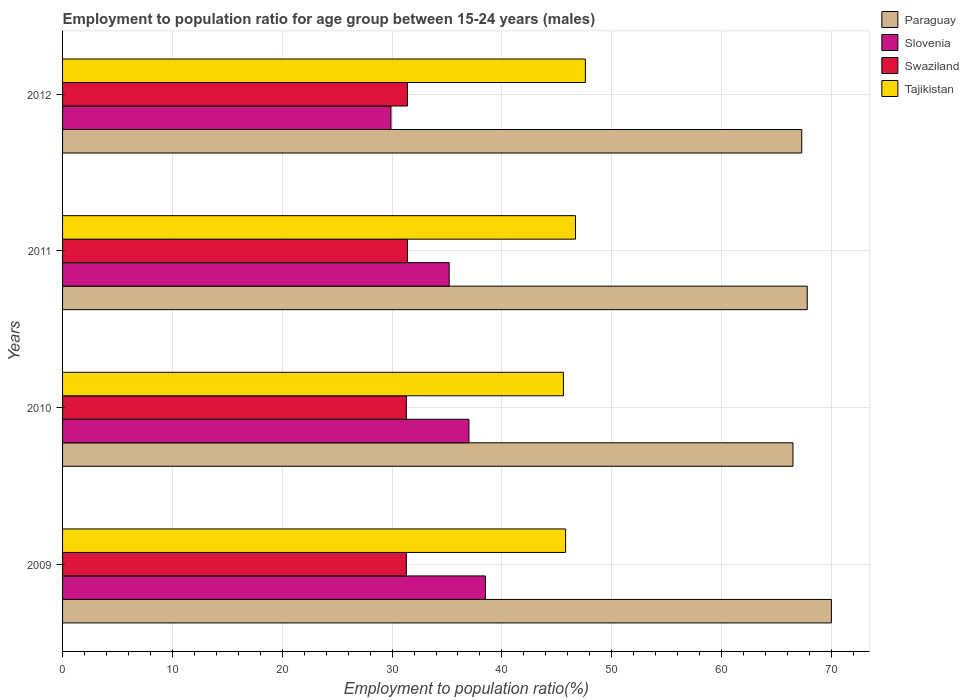How many different coloured bars are there?
Offer a terse response. 4. How many groups of bars are there?
Your response must be concise. 4. How many bars are there on the 1st tick from the bottom?
Ensure brevity in your answer.  4. In how many cases, is the number of bars for a given year not equal to the number of legend labels?
Your answer should be very brief. 0. What is the employment to population ratio in Swaziland in 2012?
Offer a very short reply. 31.4. Across all years, what is the maximum employment to population ratio in Tajikistan?
Provide a short and direct response. 47.6. Across all years, what is the minimum employment to population ratio in Paraguay?
Keep it short and to the point. 66.5. What is the total employment to population ratio in Paraguay in the graph?
Your response must be concise. 271.6. What is the difference between the employment to population ratio in Tajikistan in 2009 and the employment to population ratio in Slovenia in 2012?
Offer a terse response. 15.9. What is the average employment to population ratio in Swaziland per year?
Keep it short and to the point. 31.35. In the year 2012, what is the difference between the employment to population ratio in Paraguay and employment to population ratio in Tajikistan?
Keep it short and to the point. 19.7. What is the ratio of the employment to population ratio in Paraguay in 2010 to that in 2012?
Your answer should be compact. 0.99. Is the employment to population ratio in Slovenia in 2010 less than that in 2012?
Your response must be concise. No. What does the 2nd bar from the top in 2012 represents?
Ensure brevity in your answer.  Swaziland. What does the 1st bar from the bottom in 2010 represents?
Offer a very short reply. Paraguay. Is it the case that in every year, the sum of the employment to population ratio in Paraguay and employment to population ratio in Slovenia is greater than the employment to population ratio in Tajikistan?
Make the answer very short. Yes. What is the difference between two consecutive major ticks on the X-axis?
Your answer should be compact. 10. Are the values on the major ticks of X-axis written in scientific E-notation?
Provide a short and direct response. No. Does the graph contain grids?
Give a very brief answer. Yes. Where does the legend appear in the graph?
Offer a very short reply. Top right. How many legend labels are there?
Your answer should be very brief. 4. What is the title of the graph?
Keep it short and to the point. Employment to population ratio for age group between 15-24 years (males). Does "Kyrgyz Republic" appear as one of the legend labels in the graph?
Make the answer very short. No. What is the label or title of the X-axis?
Your answer should be very brief. Employment to population ratio(%). What is the Employment to population ratio(%) of Paraguay in 2009?
Your answer should be compact. 70. What is the Employment to population ratio(%) in Slovenia in 2009?
Make the answer very short. 38.5. What is the Employment to population ratio(%) of Swaziland in 2009?
Your response must be concise. 31.3. What is the Employment to population ratio(%) in Tajikistan in 2009?
Offer a very short reply. 45.8. What is the Employment to population ratio(%) in Paraguay in 2010?
Keep it short and to the point. 66.5. What is the Employment to population ratio(%) of Slovenia in 2010?
Provide a succinct answer. 37. What is the Employment to population ratio(%) of Swaziland in 2010?
Your answer should be very brief. 31.3. What is the Employment to population ratio(%) of Tajikistan in 2010?
Provide a short and direct response. 45.6. What is the Employment to population ratio(%) of Paraguay in 2011?
Your answer should be very brief. 67.8. What is the Employment to population ratio(%) of Slovenia in 2011?
Give a very brief answer. 35.2. What is the Employment to population ratio(%) in Swaziland in 2011?
Offer a terse response. 31.4. What is the Employment to population ratio(%) of Tajikistan in 2011?
Offer a terse response. 46.7. What is the Employment to population ratio(%) of Paraguay in 2012?
Ensure brevity in your answer.  67.3. What is the Employment to population ratio(%) of Slovenia in 2012?
Provide a short and direct response. 29.9. What is the Employment to population ratio(%) in Swaziland in 2012?
Your answer should be compact. 31.4. What is the Employment to population ratio(%) of Tajikistan in 2012?
Ensure brevity in your answer.  47.6. Across all years, what is the maximum Employment to population ratio(%) of Slovenia?
Your answer should be very brief. 38.5. Across all years, what is the maximum Employment to population ratio(%) in Swaziland?
Make the answer very short. 31.4. Across all years, what is the maximum Employment to population ratio(%) in Tajikistan?
Your response must be concise. 47.6. Across all years, what is the minimum Employment to population ratio(%) in Paraguay?
Your answer should be compact. 66.5. Across all years, what is the minimum Employment to population ratio(%) in Slovenia?
Provide a succinct answer. 29.9. Across all years, what is the minimum Employment to population ratio(%) in Swaziland?
Keep it short and to the point. 31.3. Across all years, what is the minimum Employment to population ratio(%) of Tajikistan?
Ensure brevity in your answer.  45.6. What is the total Employment to population ratio(%) in Paraguay in the graph?
Your answer should be very brief. 271.6. What is the total Employment to population ratio(%) in Slovenia in the graph?
Provide a succinct answer. 140.6. What is the total Employment to population ratio(%) in Swaziland in the graph?
Your answer should be compact. 125.4. What is the total Employment to population ratio(%) of Tajikistan in the graph?
Ensure brevity in your answer.  185.7. What is the difference between the Employment to population ratio(%) in Slovenia in 2009 and that in 2010?
Your answer should be compact. 1.5. What is the difference between the Employment to population ratio(%) of Swaziland in 2009 and that in 2010?
Offer a terse response. 0. What is the difference between the Employment to population ratio(%) of Tajikistan in 2009 and that in 2010?
Offer a very short reply. 0.2. What is the difference between the Employment to population ratio(%) in Paraguay in 2009 and that in 2011?
Make the answer very short. 2.2. What is the difference between the Employment to population ratio(%) of Slovenia in 2009 and that in 2011?
Make the answer very short. 3.3. What is the difference between the Employment to population ratio(%) of Slovenia in 2009 and that in 2012?
Give a very brief answer. 8.6. What is the difference between the Employment to population ratio(%) in Swaziland in 2009 and that in 2012?
Your response must be concise. -0.1. What is the difference between the Employment to population ratio(%) of Tajikistan in 2009 and that in 2012?
Provide a succinct answer. -1.8. What is the difference between the Employment to population ratio(%) of Paraguay in 2010 and that in 2011?
Your response must be concise. -1.3. What is the difference between the Employment to population ratio(%) of Swaziland in 2010 and that in 2011?
Offer a terse response. -0.1. What is the difference between the Employment to population ratio(%) of Tajikistan in 2010 and that in 2011?
Your response must be concise. -1.1. What is the difference between the Employment to population ratio(%) in Slovenia in 2010 and that in 2012?
Give a very brief answer. 7.1. What is the difference between the Employment to population ratio(%) in Tajikistan in 2010 and that in 2012?
Offer a terse response. -2. What is the difference between the Employment to population ratio(%) of Paraguay in 2011 and that in 2012?
Give a very brief answer. 0.5. What is the difference between the Employment to population ratio(%) in Slovenia in 2011 and that in 2012?
Make the answer very short. 5.3. What is the difference between the Employment to population ratio(%) in Tajikistan in 2011 and that in 2012?
Ensure brevity in your answer.  -0.9. What is the difference between the Employment to population ratio(%) of Paraguay in 2009 and the Employment to population ratio(%) of Slovenia in 2010?
Provide a succinct answer. 33. What is the difference between the Employment to population ratio(%) in Paraguay in 2009 and the Employment to population ratio(%) in Swaziland in 2010?
Offer a very short reply. 38.7. What is the difference between the Employment to population ratio(%) in Paraguay in 2009 and the Employment to population ratio(%) in Tajikistan in 2010?
Your answer should be compact. 24.4. What is the difference between the Employment to population ratio(%) in Swaziland in 2009 and the Employment to population ratio(%) in Tajikistan in 2010?
Your answer should be compact. -14.3. What is the difference between the Employment to population ratio(%) in Paraguay in 2009 and the Employment to population ratio(%) in Slovenia in 2011?
Make the answer very short. 34.8. What is the difference between the Employment to population ratio(%) of Paraguay in 2009 and the Employment to population ratio(%) of Swaziland in 2011?
Your answer should be very brief. 38.6. What is the difference between the Employment to population ratio(%) of Paraguay in 2009 and the Employment to population ratio(%) of Tajikistan in 2011?
Your answer should be very brief. 23.3. What is the difference between the Employment to population ratio(%) of Slovenia in 2009 and the Employment to population ratio(%) of Swaziland in 2011?
Offer a very short reply. 7.1. What is the difference between the Employment to population ratio(%) in Slovenia in 2009 and the Employment to population ratio(%) in Tajikistan in 2011?
Ensure brevity in your answer.  -8.2. What is the difference between the Employment to population ratio(%) in Swaziland in 2009 and the Employment to population ratio(%) in Tajikistan in 2011?
Offer a very short reply. -15.4. What is the difference between the Employment to population ratio(%) of Paraguay in 2009 and the Employment to population ratio(%) of Slovenia in 2012?
Your response must be concise. 40.1. What is the difference between the Employment to population ratio(%) in Paraguay in 2009 and the Employment to population ratio(%) in Swaziland in 2012?
Provide a short and direct response. 38.6. What is the difference between the Employment to population ratio(%) in Paraguay in 2009 and the Employment to population ratio(%) in Tajikistan in 2012?
Provide a succinct answer. 22.4. What is the difference between the Employment to population ratio(%) of Swaziland in 2009 and the Employment to population ratio(%) of Tajikistan in 2012?
Offer a very short reply. -16.3. What is the difference between the Employment to population ratio(%) of Paraguay in 2010 and the Employment to population ratio(%) of Slovenia in 2011?
Your answer should be compact. 31.3. What is the difference between the Employment to population ratio(%) of Paraguay in 2010 and the Employment to population ratio(%) of Swaziland in 2011?
Provide a succinct answer. 35.1. What is the difference between the Employment to population ratio(%) of Paraguay in 2010 and the Employment to population ratio(%) of Tajikistan in 2011?
Provide a succinct answer. 19.8. What is the difference between the Employment to population ratio(%) of Slovenia in 2010 and the Employment to population ratio(%) of Tajikistan in 2011?
Your answer should be compact. -9.7. What is the difference between the Employment to population ratio(%) in Swaziland in 2010 and the Employment to population ratio(%) in Tajikistan in 2011?
Offer a terse response. -15.4. What is the difference between the Employment to population ratio(%) in Paraguay in 2010 and the Employment to population ratio(%) in Slovenia in 2012?
Provide a short and direct response. 36.6. What is the difference between the Employment to population ratio(%) of Paraguay in 2010 and the Employment to population ratio(%) of Swaziland in 2012?
Ensure brevity in your answer.  35.1. What is the difference between the Employment to population ratio(%) of Paraguay in 2010 and the Employment to population ratio(%) of Tajikistan in 2012?
Provide a short and direct response. 18.9. What is the difference between the Employment to population ratio(%) in Swaziland in 2010 and the Employment to population ratio(%) in Tajikistan in 2012?
Your answer should be very brief. -16.3. What is the difference between the Employment to population ratio(%) of Paraguay in 2011 and the Employment to population ratio(%) of Slovenia in 2012?
Offer a very short reply. 37.9. What is the difference between the Employment to population ratio(%) in Paraguay in 2011 and the Employment to population ratio(%) in Swaziland in 2012?
Your response must be concise. 36.4. What is the difference between the Employment to population ratio(%) in Paraguay in 2011 and the Employment to population ratio(%) in Tajikistan in 2012?
Provide a short and direct response. 20.2. What is the difference between the Employment to population ratio(%) in Slovenia in 2011 and the Employment to population ratio(%) in Swaziland in 2012?
Make the answer very short. 3.8. What is the difference between the Employment to population ratio(%) in Slovenia in 2011 and the Employment to population ratio(%) in Tajikistan in 2012?
Your response must be concise. -12.4. What is the difference between the Employment to population ratio(%) in Swaziland in 2011 and the Employment to population ratio(%) in Tajikistan in 2012?
Make the answer very short. -16.2. What is the average Employment to population ratio(%) in Paraguay per year?
Keep it short and to the point. 67.9. What is the average Employment to population ratio(%) in Slovenia per year?
Your answer should be compact. 35.15. What is the average Employment to population ratio(%) in Swaziland per year?
Offer a very short reply. 31.35. What is the average Employment to population ratio(%) of Tajikistan per year?
Make the answer very short. 46.42. In the year 2009, what is the difference between the Employment to population ratio(%) of Paraguay and Employment to population ratio(%) of Slovenia?
Offer a very short reply. 31.5. In the year 2009, what is the difference between the Employment to population ratio(%) in Paraguay and Employment to population ratio(%) in Swaziland?
Offer a terse response. 38.7. In the year 2009, what is the difference between the Employment to population ratio(%) of Paraguay and Employment to population ratio(%) of Tajikistan?
Give a very brief answer. 24.2. In the year 2009, what is the difference between the Employment to population ratio(%) in Swaziland and Employment to population ratio(%) in Tajikistan?
Offer a very short reply. -14.5. In the year 2010, what is the difference between the Employment to population ratio(%) of Paraguay and Employment to population ratio(%) of Slovenia?
Provide a succinct answer. 29.5. In the year 2010, what is the difference between the Employment to population ratio(%) of Paraguay and Employment to population ratio(%) of Swaziland?
Offer a very short reply. 35.2. In the year 2010, what is the difference between the Employment to population ratio(%) in Paraguay and Employment to population ratio(%) in Tajikistan?
Provide a succinct answer. 20.9. In the year 2010, what is the difference between the Employment to population ratio(%) in Slovenia and Employment to population ratio(%) in Swaziland?
Keep it short and to the point. 5.7. In the year 2010, what is the difference between the Employment to population ratio(%) of Swaziland and Employment to population ratio(%) of Tajikistan?
Your answer should be compact. -14.3. In the year 2011, what is the difference between the Employment to population ratio(%) in Paraguay and Employment to population ratio(%) in Slovenia?
Offer a terse response. 32.6. In the year 2011, what is the difference between the Employment to population ratio(%) of Paraguay and Employment to population ratio(%) of Swaziland?
Your answer should be compact. 36.4. In the year 2011, what is the difference between the Employment to population ratio(%) of Paraguay and Employment to population ratio(%) of Tajikistan?
Offer a terse response. 21.1. In the year 2011, what is the difference between the Employment to population ratio(%) of Slovenia and Employment to population ratio(%) of Swaziland?
Your response must be concise. 3.8. In the year 2011, what is the difference between the Employment to population ratio(%) of Swaziland and Employment to population ratio(%) of Tajikistan?
Make the answer very short. -15.3. In the year 2012, what is the difference between the Employment to population ratio(%) of Paraguay and Employment to population ratio(%) of Slovenia?
Your response must be concise. 37.4. In the year 2012, what is the difference between the Employment to population ratio(%) in Paraguay and Employment to population ratio(%) in Swaziland?
Your response must be concise. 35.9. In the year 2012, what is the difference between the Employment to population ratio(%) of Paraguay and Employment to population ratio(%) of Tajikistan?
Give a very brief answer. 19.7. In the year 2012, what is the difference between the Employment to population ratio(%) in Slovenia and Employment to population ratio(%) in Tajikistan?
Provide a short and direct response. -17.7. In the year 2012, what is the difference between the Employment to population ratio(%) in Swaziland and Employment to population ratio(%) in Tajikistan?
Your answer should be very brief. -16.2. What is the ratio of the Employment to population ratio(%) of Paraguay in 2009 to that in 2010?
Make the answer very short. 1.05. What is the ratio of the Employment to population ratio(%) of Slovenia in 2009 to that in 2010?
Ensure brevity in your answer.  1.04. What is the ratio of the Employment to population ratio(%) of Swaziland in 2009 to that in 2010?
Offer a terse response. 1. What is the ratio of the Employment to population ratio(%) of Paraguay in 2009 to that in 2011?
Give a very brief answer. 1.03. What is the ratio of the Employment to population ratio(%) in Slovenia in 2009 to that in 2011?
Offer a very short reply. 1.09. What is the ratio of the Employment to population ratio(%) of Tajikistan in 2009 to that in 2011?
Keep it short and to the point. 0.98. What is the ratio of the Employment to population ratio(%) in Paraguay in 2009 to that in 2012?
Your response must be concise. 1.04. What is the ratio of the Employment to population ratio(%) in Slovenia in 2009 to that in 2012?
Provide a succinct answer. 1.29. What is the ratio of the Employment to population ratio(%) of Swaziland in 2009 to that in 2012?
Provide a short and direct response. 1. What is the ratio of the Employment to population ratio(%) of Tajikistan in 2009 to that in 2012?
Offer a terse response. 0.96. What is the ratio of the Employment to population ratio(%) of Paraguay in 2010 to that in 2011?
Your answer should be compact. 0.98. What is the ratio of the Employment to population ratio(%) in Slovenia in 2010 to that in 2011?
Make the answer very short. 1.05. What is the ratio of the Employment to population ratio(%) in Swaziland in 2010 to that in 2011?
Your answer should be very brief. 1. What is the ratio of the Employment to population ratio(%) of Tajikistan in 2010 to that in 2011?
Provide a short and direct response. 0.98. What is the ratio of the Employment to population ratio(%) of Paraguay in 2010 to that in 2012?
Offer a very short reply. 0.99. What is the ratio of the Employment to population ratio(%) in Slovenia in 2010 to that in 2012?
Provide a short and direct response. 1.24. What is the ratio of the Employment to population ratio(%) in Tajikistan in 2010 to that in 2012?
Give a very brief answer. 0.96. What is the ratio of the Employment to population ratio(%) in Paraguay in 2011 to that in 2012?
Your response must be concise. 1.01. What is the ratio of the Employment to population ratio(%) of Slovenia in 2011 to that in 2012?
Your answer should be compact. 1.18. What is the ratio of the Employment to population ratio(%) of Tajikistan in 2011 to that in 2012?
Provide a short and direct response. 0.98. What is the difference between the highest and the second highest Employment to population ratio(%) in Slovenia?
Offer a terse response. 1.5. What is the difference between the highest and the second highest Employment to population ratio(%) in Swaziland?
Ensure brevity in your answer.  0. What is the difference between the highest and the second highest Employment to population ratio(%) in Tajikistan?
Your answer should be compact. 0.9. What is the difference between the highest and the lowest Employment to population ratio(%) of Swaziland?
Your answer should be very brief. 0.1. 